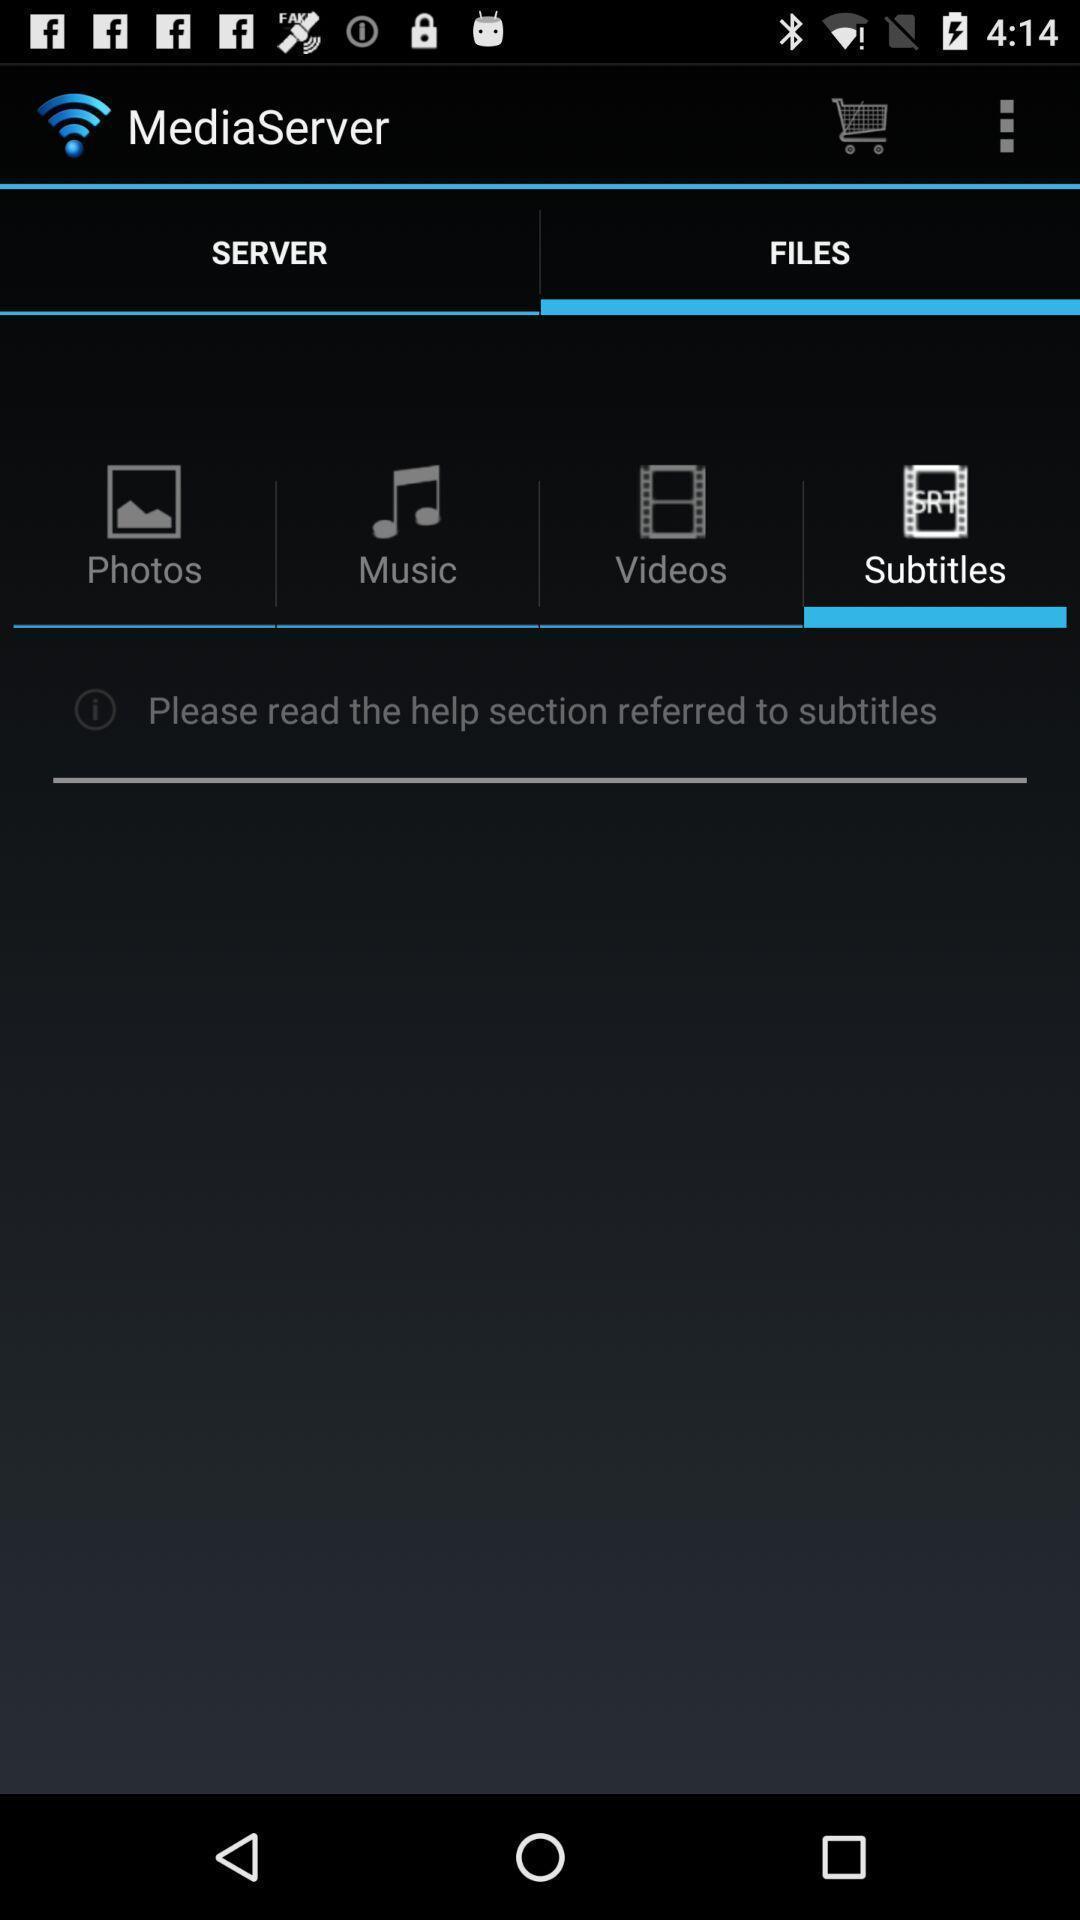Summarize the information in this screenshot. Subtitles of files in media server. 